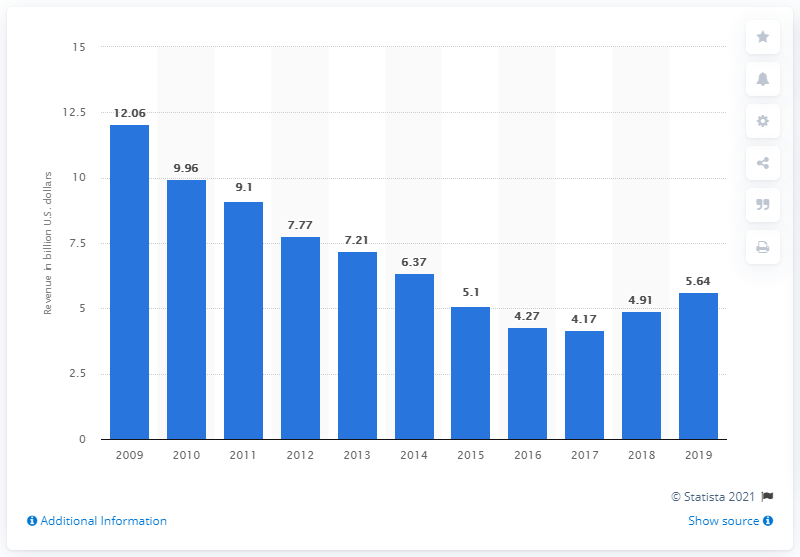Give some essential details in this illustration. KBR Inc. was founded in the year 2009. In the fiscal year of 2019, KBR generated approximately 5.64 million in revenue. 